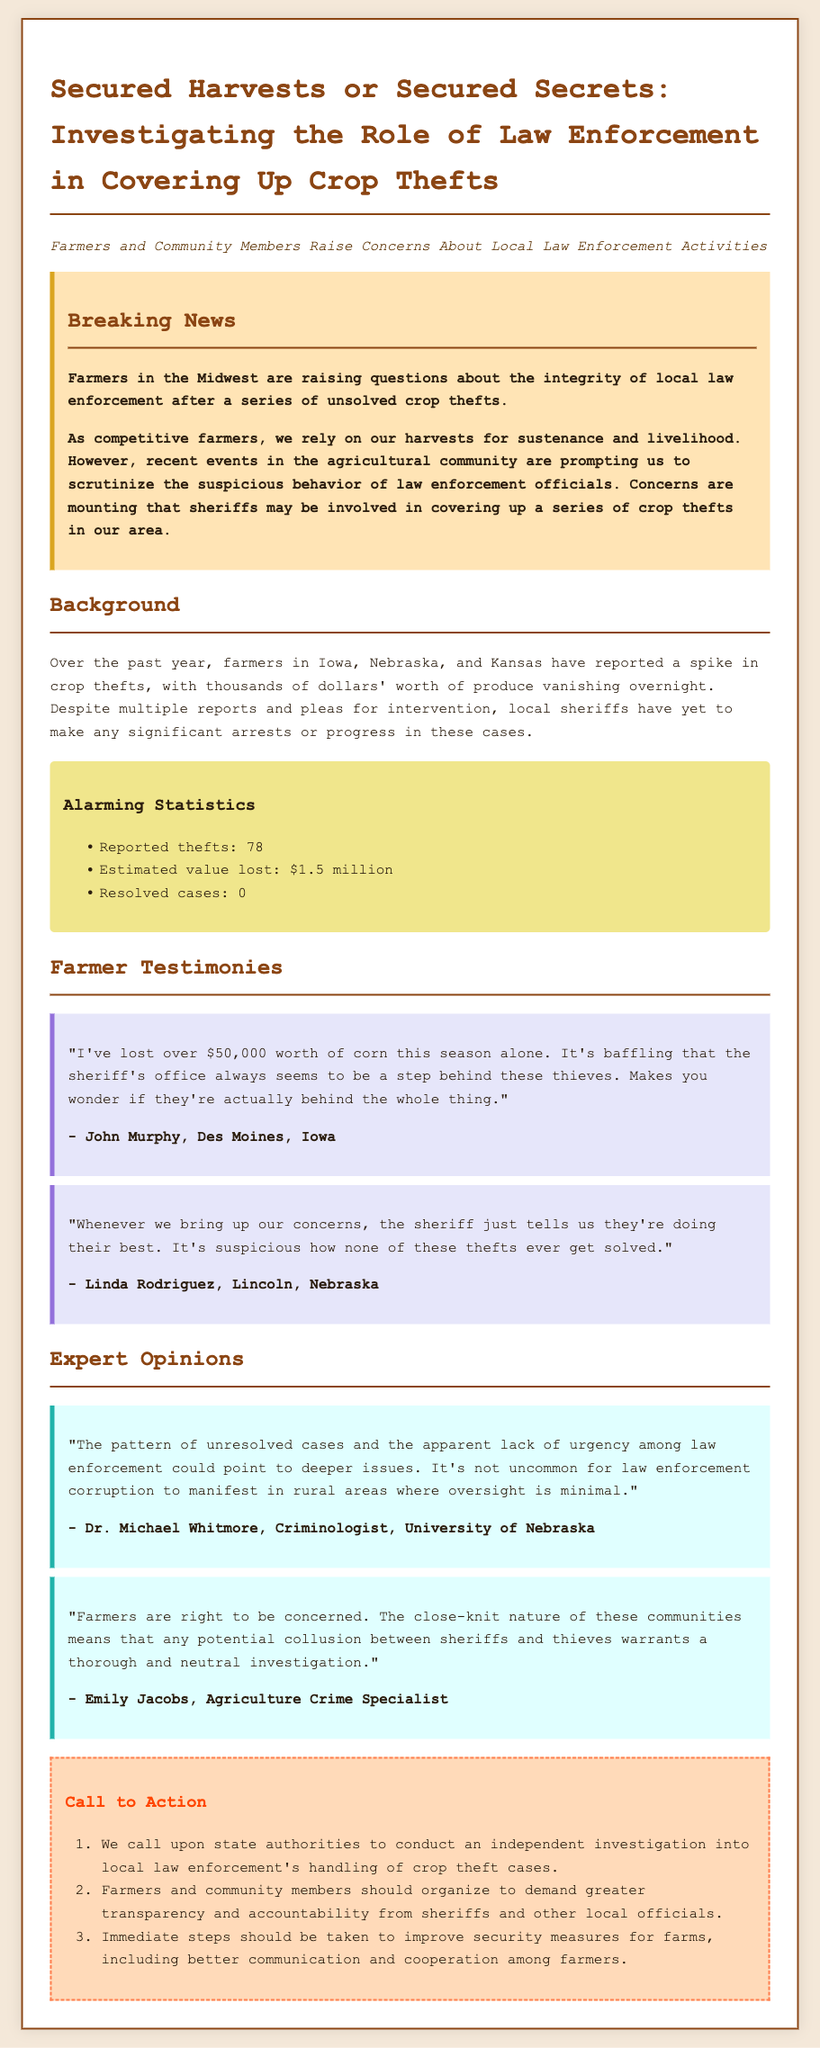What is the title of the press release? The title provides the main subject of the document, which is "Secured Harvests or Secured Secrets: Investigating the Role of Law Enforcement in Covering Up Crop Thefts."
Answer: Secured Harvests or Secured Secrets: Investigating the Role of Law Enforcement in Covering Up Crop Thefts How many reported thefts are mentioned? The document cites a specific number of thefts reported, which is noted in the statistics section.
Answer: 78 What is the estimated value lost due to thefts? The estimated loss is given as a specific dollar amount in the statistics section.
Answer: $1.5 million Who is quoted expressing suspicion about law enforcement? The document includes direct quotes from farmers, one of whom explicitly expresses suspicion about local law enforcement regarding thefts.
Answer: John Murphy What action do farmers want state authorities to take? There is a specific call to action that mentions what farmers are requesting from authorities, outlined in the "Call to Action" section.
Answer: Conduct an independent investigation How many resolved cases are reported in the document? The document mentions how many cases have been resolved, which is detailed in the statistics section.
Answer: 0 What year did the crop theft reports start increasing? The background section mentions the duration of the thefts and the context of rising concerns in the agricultural community.
Answer: Past year Who emphasizes the need for a thorough investigation? The document contains quotes from experts who highlight the necessity for a thorough investigation into law enforcement actions.
Answer: Emily Jacobs What are farmers urged to organize for? The call to action specifies the purpose for which farmers and community members should rally.
Answer: Greater transparency and accountability 